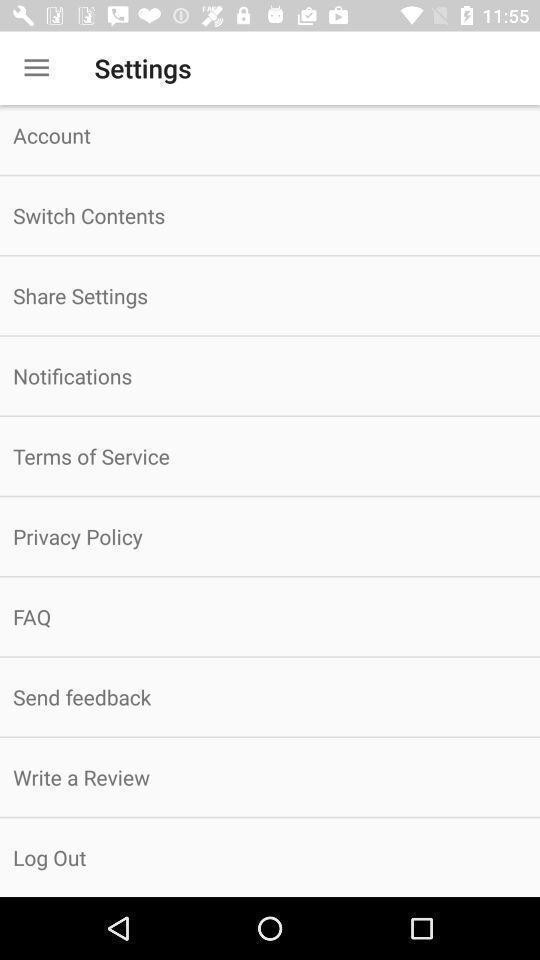Give me a narrative description of this picture. Screen shows about account settings. 